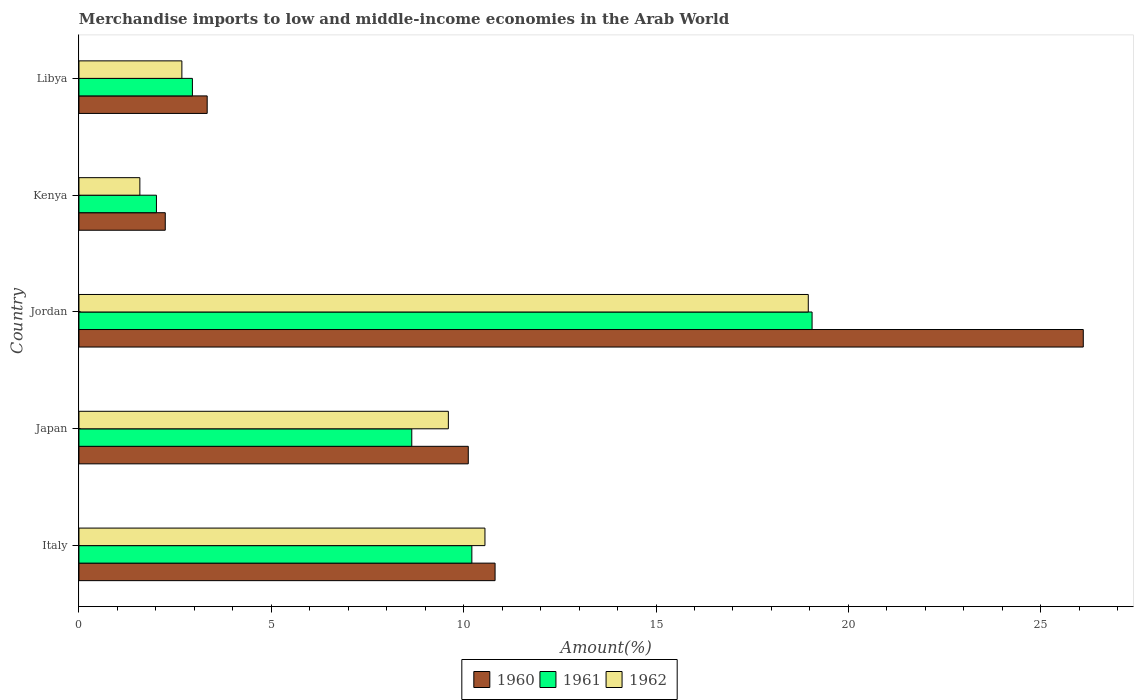Are the number of bars on each tick of the Y-axis equal?
Keep it short and to the point. Yes. How many bars are there on the 2nd tick from the bottom?
Your answer should be very brief. 3. What is the label of the 4th group of bars from the top?
Make the answer very short. Japan. What is the percentage of amount earned from merchandise imports in 1961 in Japan?
Provide a succinct answer. 8.65. Across all countries, what is the maximum percentage of amount earned from merchandise imports in 1960?
Your answer should be compact. 26.11. Across all countries, what is the minimum percentage of amount earned from merchandise imports in 1960?
Provide a succinct answer. 2.24. In which country was the percentage of amount earned from merchandise imports in 1961 maximum?
Your answer should be compact. Jordan. In which country was the percentage of amount earned from merchandise imports in 1962 minimum?
Make the answer very short. Kenya. What is the total percentage of amount earned from merchandise imports in 1960 in the graph?
Your answer should be compact. 52.62. What is the difference between the percentage of amount earned from merchandise imports in 1960 in Italy and that in Jordan?
Offer a very short reply. -15.29. What is the difference between the percentage of amount earned from merchandise imports in 1962 in Italy and the percentage of amount earned from merchandise imports in 1960 in Libya?
Provide a succinct answer. 7.22. What is the average percentage of amount earned from merchandise imports in 1961 per country?
Provide a short and direct response. 8.58. What is the difference between the percentage of amount earned from merchandise imports in 1961 and percentage of amount earned from merchandise imports in 1960 in Libya?
Provide a succinct answer. -0.38. In how many countries, is the percentage of amount earned from merchandise imports in 1962 greater than 15 %?
Provide a short and direct response. 1. What is the ratio of the percentage of amount earned from merchandise imports in 1961 in Japan to that in Jordan?
Your answer should be very brief. 0.45. What is the difference between the highest and the second highest percentage of amount earned from merchandise imports in 1962?
Your answer should be compact. 8.4. What is the difference between the highest and the lowest percentage of amount earned from merchandise imports in 1962?
Your answer should be compact. 17.37. In how many countries, is the percentage of amount earned from merchandise imports in 1962 greater than the average percentage of amount earned from merchandise imports in 1962 taken over all countries?
Offer a very short reply. 3. What does the 1st bar from the top in Jordan represents?
Make the answer very short. 1962. Is it the case that in every country, the sum of the percentage of amount earned from merchandise imports in 1961 and percentage of amount earned from merchandise imports in 1960 is greater than the percentage of amount earned from merchandise imports in 1962?
Your response must be concise. Yes. How many bars are there?
Offer a very short reply. 15. How many countries are there in the graph?
Your response must be concise. 5. Are the values on the major ticks of X-axis written in scientific E-notation?
Keep it short and to the point. No. Does the graph contain any zero values?
Offer a very short reply. No. Does the graph contain grids?
Ensure brevity in your answer.  No. How are the legend labels stacked?
Keep it short and to the point. Horizontal. What is the title of the graph?
Your answer should be very brief. Merchandise imports to low and middle-income economies in the Arab World. Does "1961" appear as one of the legend labels in the graph?
Make the answer very short. Yes. What is the label or title of the X-axis?
Make the answer very short. Amount(%). What is the Amount(%) in 1960 in Italy?
Your response must be concise. 10.82. What is the Amount(%) of 1961 in Italy?
Give a very brief answer. 10.21. What is the Amount(%) in 1962 in Italy?
Provide a short and direct response. 10.55. What is the Amount(%) in 1960 in Japan?
Keep it short and to the point. 10.12. What is the Amount(%) in 1961 in Japan?
Your answer should be compact. 8.65. What is the Amount(%) of 1962 in Japan?
Make the answer very short. 9.6. What is the Amount(%) of 1960 in Jordan?
Your answer should be compact. 26.11. What is the Amount(%) of 1961 in Jordan?
Your response must be concise. 19.06. What is the Amount(%) in 1962 in Jordan?
Offer a very short reply. 18.96. What is the Amount(%) in 1960 in Kenya?
Provide a succinct answer. 2.24. What is the Amount(%) of 1961 in Kenya?
Your answer should be compact. 2.01. What is the Amount(%) in 1962 in Kenya?
Provide a short and direct response. 1.58. What is the Amount(%) in 1960 in Libya?
Ensure brevity in your answer.  3.33. What is the Amount(%) in 1961 in Libya?
Your response must be concise. 2.95. What is the Amount(%) of 1962 in Libya?
Provide a succinct answer. 2.68. Across all countries, what is the maximum Amount(%) in 1960?
Give a very brief answer. 26.11. Across all countries, what is the maximum Amount(%) in 1961?
Provide a succinct answer. 19.06. Across all countries, what is the maximum Amount(%) in 1962?
Make the answer very short. 18.96. Across all countries, what is the minimum Amount(%) in 1960?
Keep it short and to the point. 2.24. Across all countries, what is the minimum Amount(%) of 1961?
Give a very brief answer. 2.01. Across all countries, what is the minimum Amount(%) of 1962?
Your answer should be very brief. 1.58. What is the total Amount(%) of 1960 in the graph?
Make the answer very short. 52.62. What is the total Amount(%) in 1961 in the graph?
Provide a succinct answer. 42.88. What is the total Amount(%) of 1962 in the graph?
Your response must be concise. 43.37. What is the difference between the Amount(%) in 1960 in Italy and that in Japan?
Your answer should be compact. 0.7. What is the difference between the Amount(%) in 1961 in Italy and that in Japan?
Your answer should be compact. 1.56. What is the difference between the Amount(%) of 1962 in Italy and that in Japan?
Provide a short and direct response. 0.95. What is the difference between the Amount(%) of 1960 in Italy and that in Jordan?
Provide a short and direct response. -15.29. What is the difference between the Amount(%) in 1961 in Italy and that in Jordan?
Your answer should be compact. -8.84. What is the difference between the Amount(%) of 1962 in Italy and that in Jordan?
Provide a short and direct response. -8.4. What is the difference between the Amount(%) in 1960 in Italy and that in Kenya?
Offer a very short reply. 8.57. What is the difference between the Amount(%) of 1961 in Italy and that in Kenya?
Keep it short and to the point. 8.2. What is the difference between the Amount(%) of 1962 in Italy and that in Kenya?
Ensure brevity in your answer.  8.97. What is the difference between the Amount(%) in 1960 in Italy and that in Libya?
Provide a short and direct response. 7.48. What is the difference between the Amount(%) in 1961 in Italy and that in Libya?
Your answer should be compact. 7.26. What is the difference between the Amount(%) in 1962 in Italy and that in Libya?
Offer a very short reply. 7.88. What is the difference between the Amount(%) of 1960 in Japan and that in Jordan?
Provide a short and direct response. -15.99. What is the difference between the Amount(%) of 1961 in Japan and that in Jordan?
Offer a very short reply. -10.4. What is the difference between the Amount(%) of 1962 in Japan and that in Jordan?
Provide a short and direct response. -9.36. What is the difference between the Amount(%) in 1960 in Japan and that in Kenya?
Your answer should be compact. 7.88. What is the difference between the Amount(%) in 1961 in Japan and that in Kenya?
Offer a terse response. 6.64. What is the difference between the Amount(%) of 1962 in Japan and that in Kenya?
Your answer should be very brief. 8.02. What is the difference between the Amount(%) in 1960 in Japan and that in Libya?
Ensure brevity in your answer.  6.79. What is the difference between the Amount(%) in 1961 in Japan and that in Libya?
Your answer should be very brief. 5.7. What is the difference between the Amount(%) of 1962 in Japan and that in Libya?
Your answer should be very brief. 6.93. What is the difference between the Amount(%) of 1960 in Jordan and that in Kenya?
Offer a terse response. 23.86. What is the difference between the Amount(%) of 1961 in Jordan and that in Kenya?
Ensure brevity in your answer.  17.04. What is the difference between the Amount(%) in 1962 in Jordan and that in Kenya?
Your answer should be very brief. 17.37. What is the difference between the Amount(%) of 1960 in Jordan and that in Libya?
Your response must be concise. 22.77. What is the difference between the Amount(%) of 1961 in Jordan and that in Libya?
Offer a terse response. 16.11. What is the difference between the Amount(%) in 1962 in Jordan and that in Libya?
Your answer should be very brief. 16.28. What is the difference between the Amount(%) of 1960 in Kenya and that in Libya?
Keep it short and to the point. -1.09. What is the difference between the Amount(%) in 1961 in Kenya and that in Libya?
Provide a short and direct response. -0.94. What is the difference between the Amount(%) of 1962 in Kenya and that in Libya?
Your response must be concise. -1.09. What is the difference between the Amount(%) in 1960 in Italy and the Amount(%) in 1961 in Japan?
Provide a short and direct response. 2.17. What is the difference between the Amount(%) in 1960 in Italy and the Amount(%) in 1962 in Japan?
Ensure brevity in your answer.  1.21. What is the difference between the Amount(%) of 1961 in Italy and the Amount(%) of 1962 in Japan?
Offer a terse response. 0.61. What is the difference between the Amount(%) of 1960 in Italy and the Amount(%) of 1961 in Jordan?
Offer a very short reply. -8.24. What is the difference between the Amount(%) in 1960 in Italy and the Amount(%) in 1962 in Jordan?
Keep it short and to the point. -8.14. What is the difference between the Amount(%) of 1961 in Italy and the Amount(%) of 1962 in Jordan?
Your answer should be compact. -8.74. What is the difference between the Amount(%) of 1960 in Italy and the Amount(%) of 1961 in Kenya?
Offer a very short reply. 8.8. What is the difference between the Amount(%) in 1960 in Italy and the Amount(%) in 1962 in Kenya?
Your response must be concise. 9.23. What is the difference between the Amount(%) of 1961 in Italy and the Amount(%) of 1962 in Kenya?
Your response must be concise. 8.63. What is the difference between the Amount(%) in 1960 in Italy and the Amount(%) in 1961 in Libya?
Keep it short and to the point. 7.87. What is the difference between the Amount(%) in 1960 in Italy and the Amount(%) in 1962 in Libya?
Ensure brevity in your answer.  8.14. What is the difference between the Amount(%) in 1961 in Italy and the Amount(%) in 1962 in Libya?
Ensure brevity in your answer.  7.54. What is the difference between the Amount(%) of 1960 in Japan and the Amount(%) of 1961 in Jordan?
Keep it short and to the point. -8.94. What is the difference between the Amount(%) in 1960 in Japan and the Amount(%) in 1962 in Jordan?
Offer a very short reply. -8.84. What is the difference between the Amount(%) of 1961 in Japan and the Amount(%) of 1962 in Jordan?
Ensure brevity in your answer.  -10.31. What is the difference between the Amount(%) in 1960 in Japan and the Amount(%) in 1961 in Kenya?
Provide a short and direct response. 8.11. What is the difference between the Amount(%) in 1960 in Japan and the Amount(%) in 1962 in Kenya?
Your response must be concise. 8.54. What is the difference between the Amount(%) of 1961 in Japan and the Amount(%) of 1962 in Kenya?
Offer a very short reply. 7.07. What is the difference between the Amount(%) in 1960 in Japan and the Amount(%) in 1961 in Libya?
Your answer should be compact. 7.17. What is the difference between the Amount(%) of 1960 in Japan and the Amount(%) of 1962 in Libya?
Give a very brief answer. 7.44. What is the difference between the Amount(%) in 1961 in Japan and the Amount(%) in 1962 in Libya?
Give a very brief answer. 5.98. What is the difference between the Amount(%) of 1960 in Jordan and the Amount(%) of 1961 in Kenya?
Provide a short and direct response. 24.09. What is the difference between the Amount(%) of 1960 in Jordan and the Amount(%) of 1962 in Kenya?
Provide a succinct answer. 24.52. What is the difference between the Amount(%) in 1961 in Jordan and the Amount(%) in 1962 in Kenya?
Offer a terse response. 17.47. What is the difference between the Amount(%) in 1960 in Jordan and the Amount(%) in 1961 in Libya?
Offer a very short reply. 23.16. What is the difference between the Amount(%) in 1960 in Jordan and the Amount(%) in 1962 in Libya?
Your response must be concise. 23.43. What is the difference between the Amount(%) of 1961 in Jordan and the Amount(%) of 1962 in Libya?
Keep it short and to the point. 16.38. What is the difference between the Amount(%) in 1960 in Kenya and the Amount(%) in 1961 in Libya?
Provide a succinct answer. -0.71. What is the difference between the Amount(%) of 1960 in Kenya and the Amount(%) of 1962 in Libya?
Ensure brevity in your answer.  -0.43. What is the difference between the Amount(%) of 1961 in Kenya and the Amount(%) of 1962 in Libya?
Give a very brief answer. -0.66. What is the average Amount(%) in 1960 per country?
Keep it short and to the point. 10.52. What is the average Amount(%) in 1961 per country?
Your answer should be compact. 8.58. What is the average Amount(%) in 1962 per country?
Give a very brief answer. 8.67. What is the difference between the Amount(%) of 1960 and Amount(%) of 1961 in Italy?
Make the answer very short. 0.6. What is the difference between the Amount(%) of 1960 and Amount(%) of 1962 in Italy?
Your response must be concise. 0.26. What is the difference between the Amount(%) of 1961 and Amount(%) of 1962 in Italy?
Provide a succinct answer. -0.34. What is the difference between the Amount(%) of 1960 and Amount(%) of 1961 in Japan?
Ensure brevity in your answer.  1.47. What is the difference between the Amount(%) of 1960 and Amount(%) of 1962 in Japan?
Your answer should be compact. 0.52. What is the difference between the Amount(%) in 1961 and Amount(%) in 1962 in Japan?
Offer a terse response. -0.95. What is the difference between the Amount(%) of 1960 and Amount(%) of 1961 in Jordan?
Your answer should be compact. 7.05. What is the difference between the Amount(%) in 1960 and Amount(%) in 1962 in Jordan?
Offer a terse response. 7.15. What is the difference between the Amount(%) of 1961 and Amount(%) of 1962 in Jordan?
Your answer should be compact. 0.1. What is the difference between the Amount(%) of 1960 and Amount(%) of 1961 in Kenya?
Provide a succinct answer. 0.23. What is the difference between the Amount(%) of 1960 and Amount(%) of 1962 in Kenya?
Offer a very short reply. 0.66. What is the difference between the Amount(%) in 1961 and Amount(%) in 1962 in Kenya?
Make the answer very short. 0.43. What is the difference between the Amount(%) of 1960 and Amount(%) of 1961 in Libya?
Provide a short and direct response. 0.38. What is the difference between the Amount(%) of 1960 and Amount(%) of 1962 in Libya?
Offer a very short reply. 0.66. What is the difference between the Amount(%) of 1961 and Amount(%) of 1962 in Libya?
Give a very brief answer. 0.27. What is the ratio of the Amount(%) in 1960 in Italy to that in Japan?
Ensure brevity in your answer.  1.07. What is the ratio of the Amount(%) of 1961 in Italy to that in Japan?
Ensure brevity in your answer.  1.18. What is the ratio of the Amount(%) of 1962 in Italy to that in Japan?
Give a very brief answer. 1.1. What is the ratio of the Amount(%) of 1960 in Italy to that in Jordan?
Your response must be concise. 0.41. What is the ratio of the Amount(%) in 1961 in Italy to that in Jordan?
Make the answer very short. 0.54. What is the ratio of the Amount(%) in 1962 in Italy to that in Jordan?
Provide a short and direct response. 0.56. What is the ratio of the Amount(%) of 1960 in Italy to that in Kenya?
Keep it short and to the point. 4.82. What is the ratio of the Amount(%) of 1961 in Italy to that in Kenya?
Provide a short and direct response. 5.07. What is the ratio of the Amount(%) in 1962 in Italy to that in Kenya?
Make the answer very short. 6.67. What is the ratio of the Amount(%) of 1960 in Italy to that in Libya?
Your answer should be very brief. 3.24. What is the ratio of the Amount(%) in 1961 in Italy to that in Libya?
Provide a succinct answer. 3.46. What is the ratio of the Amount(%) of 1962 in Italy to that in Libya?
Provide a short and direct response. 3.94. What is the ratio of the Amount(%) of 1960 in Japan to that in Jordan?
Give a very brief answer. 0.39. What is the ratio of the Amount(%) in 1961 in Japan to that in Jordan?
Provide a short and direct response. 0.45. What is the ratio of the Amount(%) in 1962 in Japan to that in Jordan?
Ensure brevity in your answer.  0.51. What is the ratio of the Amount(%) of 1960 in Japan to that in Kenya?
Ensure brevity in your answer.  4.51. What is the ratio of the Amount(%) in 1961 in Japan to that in Kenya?
Your response must be concise. 4.3. What is the ratio of the Amount(%) in 1962 in Japan to that in Kenya?
Offer a terse response. 6.07. What is the ratio of the Amount(%) in 1960 in Japan to that in Libya?
Provide a short and direct response. 3.04. What is the ratio of the Amount(%) in 1961 in Japan to that in Libya?
Give a very brief answer. 2.93. What is the ratio of the Amount(%) of 1962 in Japan to that in Libya?
Keep it short and to the point. 3.59. What is the ratio of the Amount(%) of 1960 in Jordan to that in Kenya?
Provide a short and direct response. 11.64. What is the ratio of the Amount(%) in 1961 in Jordan to that in Kenya?
Your answer should be compact. 9.46. What is the ratio of the Amount(%) in 1962 in Jordan to that in Kenya?
Offer a terse response. 11.98. What is the ratio of the Amount(%) in 1960 in Jordan to that in Libya?
Your answer should be very brief. 7.83. What is the ratio of the Amount(%) of 1961 in Jordan to that in Libya?
Ensure brevity in your answer.  6.46. What is the ratio of the Amount(%) in 1962 in Jordan to that in Libya?
Offer a terse response. 7.09. What is the ratio of the Amount(%) in 1960 in Kenya to that in Libya?
Your response must be concise. 0.67. What is the ratio of the Amount(%) in 1961 in Kenya to that in Libya?
Give a very brief answer. 0.68. What is the ratio of the Amount(%) of 1962 in Kenya to that in Libya?
Your answer should be compact. 0.59. What is the difference between the highest and the second highest Amount(%) of 1960?
Provide a succinct answer. 15.29. What is the difference between the highest and the second highest Amount(%) in 1961?
Provide a succinct answer. 8.84. What is the difference between the highest and the second highest Amount(%) in 1962?
Ensure brevity in your answer.  8.4. What is the difference between the highest and the lowest Amount(%) of 1960?
Your answer should be very brief. 23.86. What is the difference between the highest and the lowest Amount(%) of 1961?
Make the answer very short. 17.04. What is the difference between the highest and the lowest Amount(%) of 1962?
Provide a short and direct response. 17.37. 